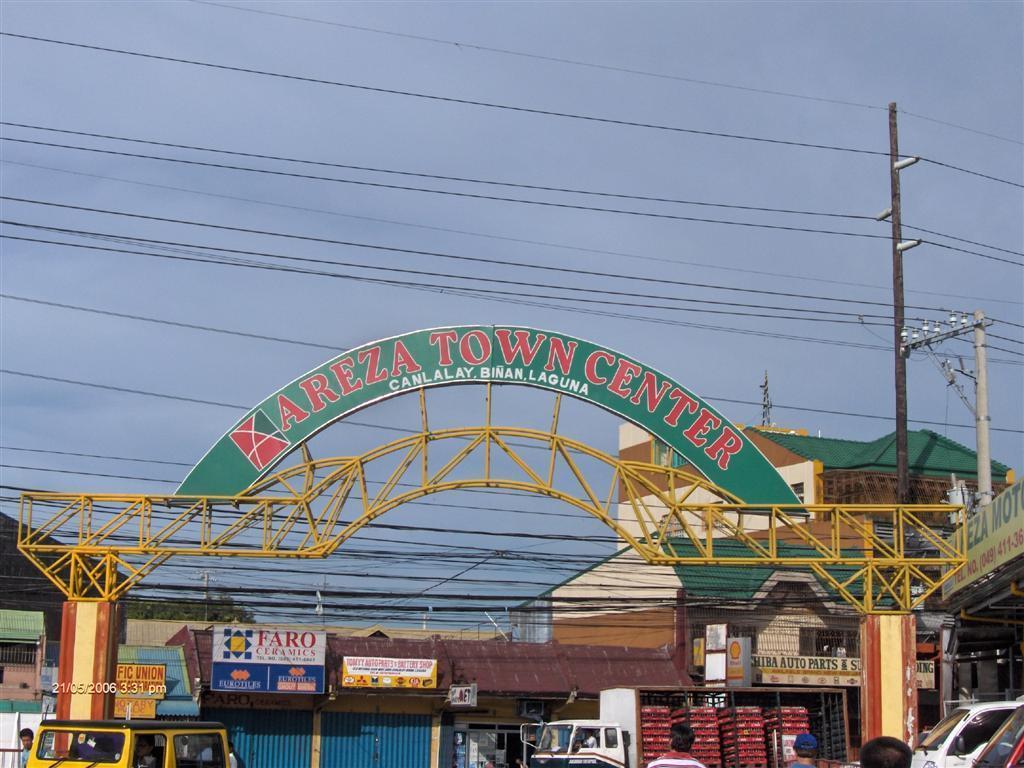Please provide a concise description of this image. In the picture we can see some persons walking, there are some vehicles, there is an arch and in the background of the picture there are some buildings and top of the picture there are some wires, there is clear sky. 